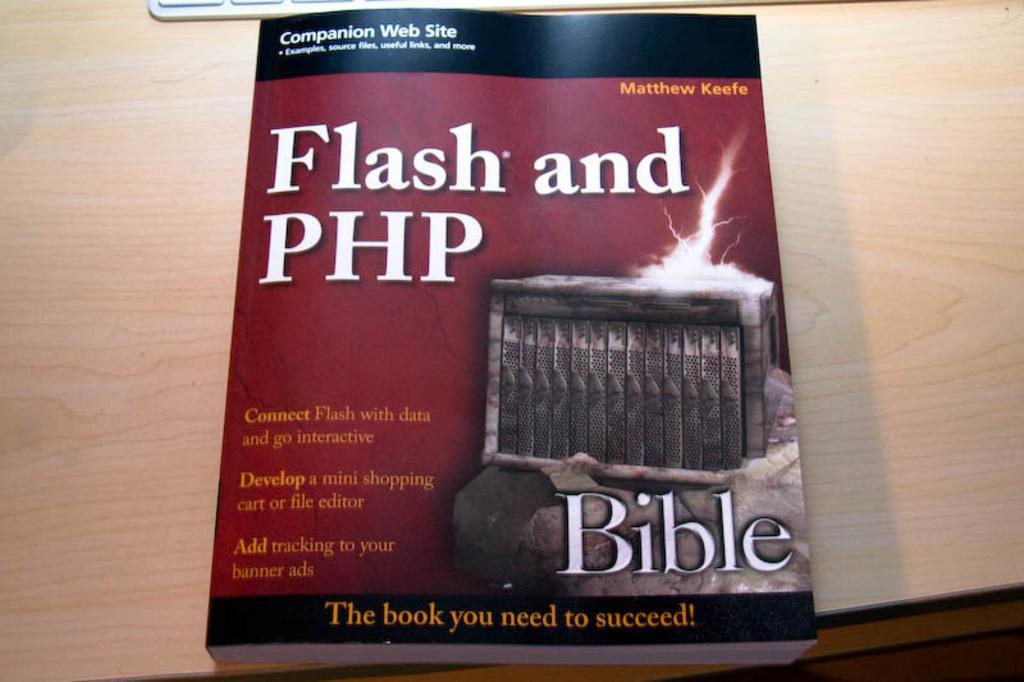Provide a one-sentence caption for the provided image. A book on a wooden table about Flash and PHP. 